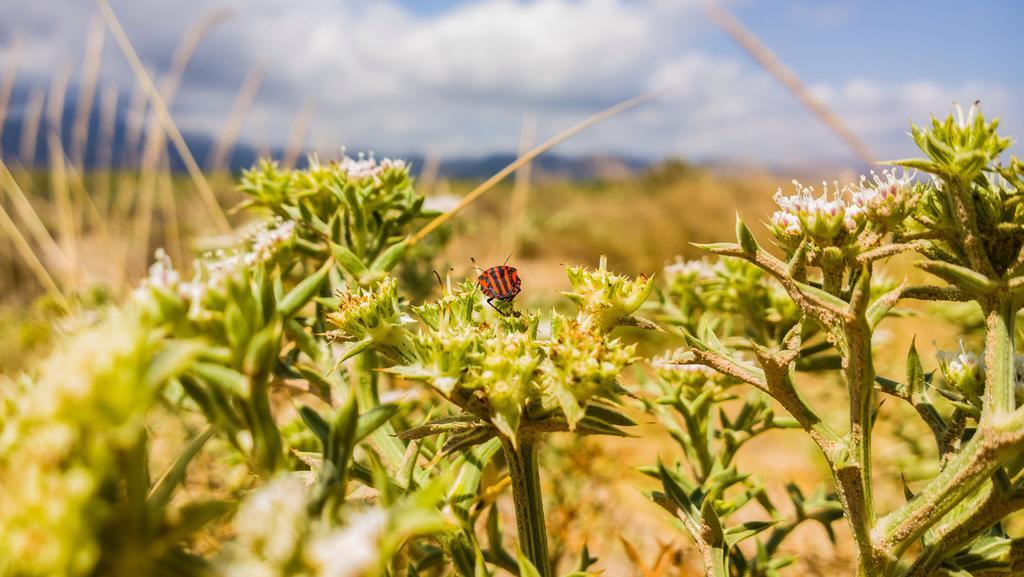In one or two sentences, can you explain what this image depicts? In this image there are plants with flowers, there is an insect on the flower of a plant , and there is blur background. 